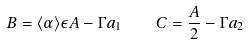<formula> <loc_0><loc_0><loc_500><loc_500>B = \langle \alpha \rangle \epsilon A - \Gamma a _ { 1 } \quad C = \frac { A } { 2 } - \Gamma a _ { 2 }</formula> 